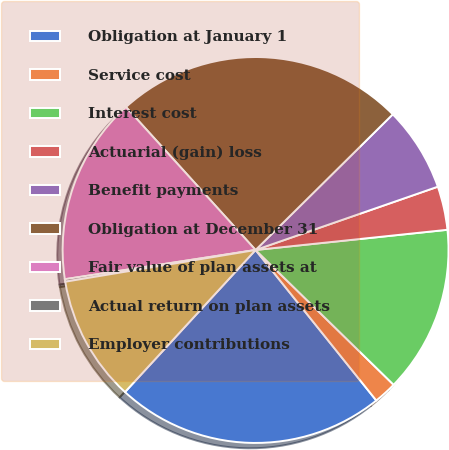Convert chart. <chart><loc_0><loc_0><loc_500><loc_500><pie_chart><fcel>Obligation at January 1<fcel>Service cost<fcel>Interest cost<fcel>Actuarial (gain) loss<fcel>Benefit payments<fcel>Obligation at December 31<fcel>Fair value of plan assets at<fcel>Actual return on plan assets<fcel>Employer contributions<nl><fcel>22.59%<fcel>1.93%<fcel>13.98%<fcel>3.65%<fcel>7.09%<fcel>24.31%<fcel>15.7%<fcel>0.21%<fcel>10.54%<nl></chart> 